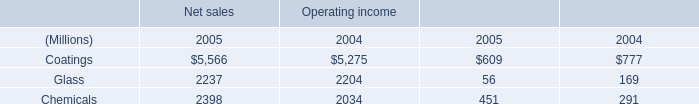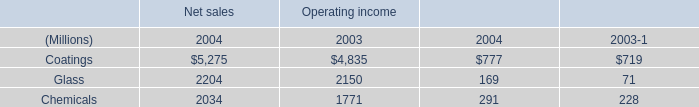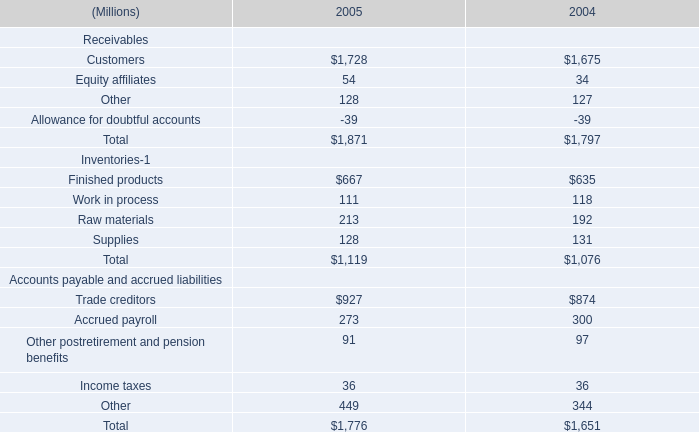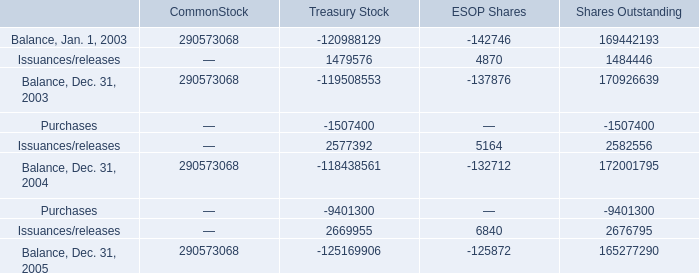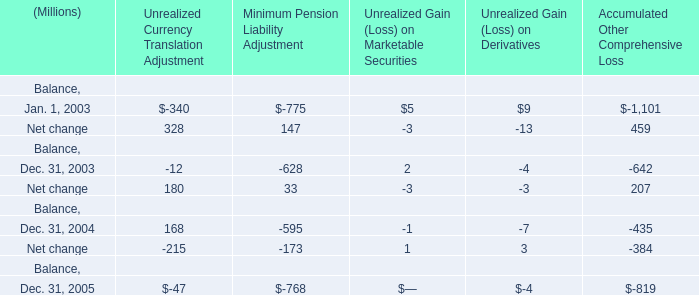What do all Net change sum up, excluding those negative ones in 2003 ? (in million) 
Computations: (328 + 147)
Answer: 475.0. 